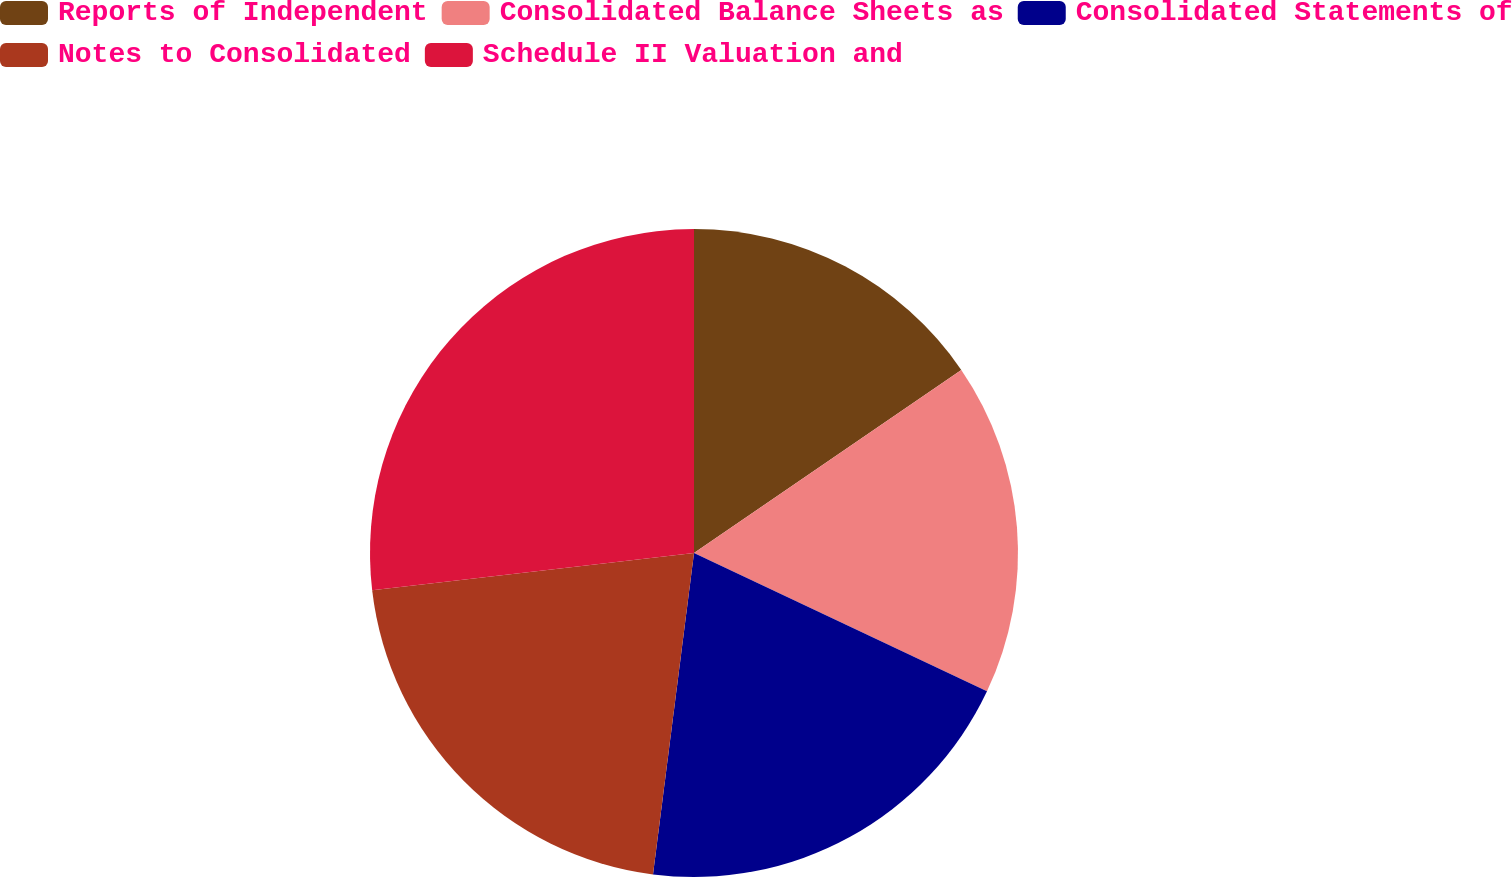Convert chart to OTSL. <chart><loc_0><loc_0><loc_500><loc_500><pie_chart><fcel>Reports of Independent<fcel>Consolidated Balance Sheets as<fcel>Consolidated Statements of<fcel>Notes to Consolidated<fcel>Schedule II Valuation and<nl><fcel>15.44%<fcel>16.58%<fcel>20.0%<fcel>21.14%<fcel>26.84%<nl></chart> 